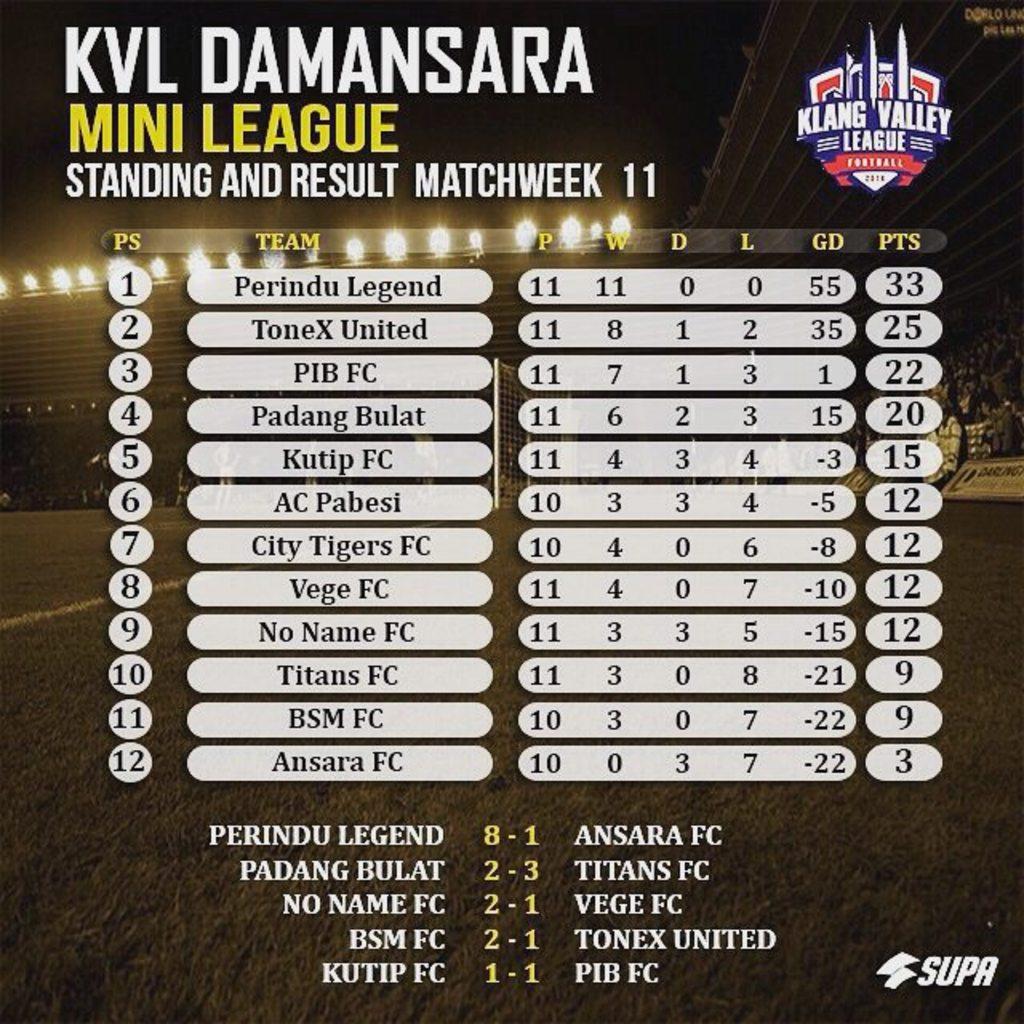Who is winning?
Your answer should be compact. Perindu legend. What kind of league is this for?
Give a very brief answer. Football. 